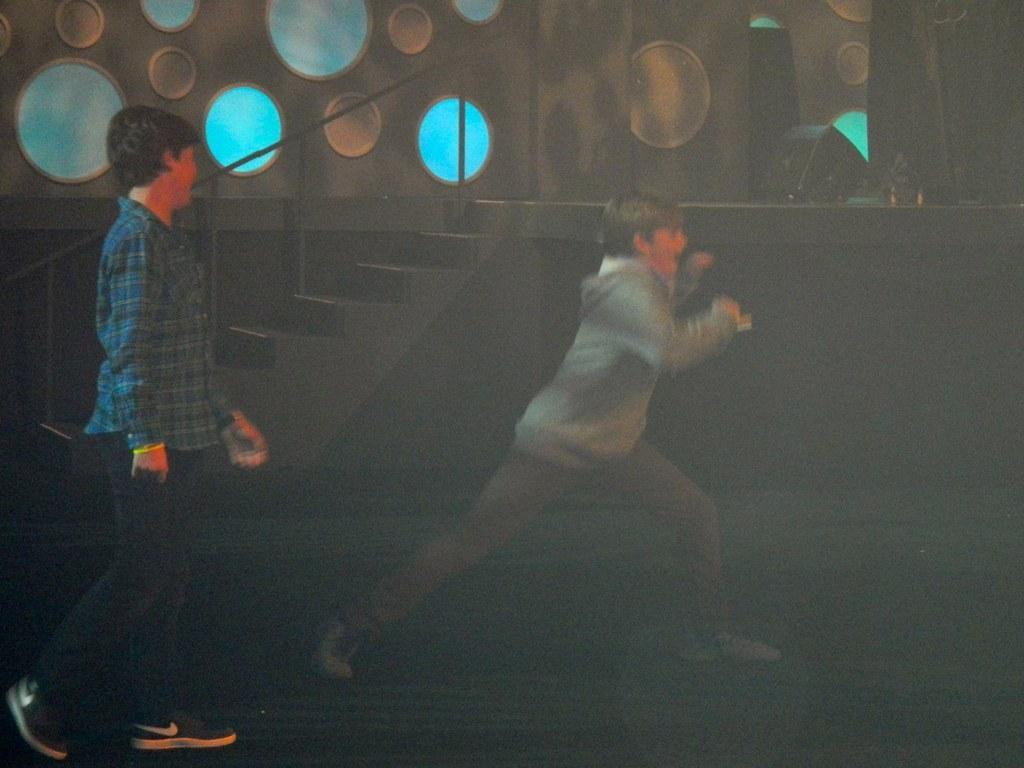Describe this image in one or two sentences. In this image we can see two persons. Behind the persons we can see the stairs, light and the wall. On the wall we can see the circular objects. 